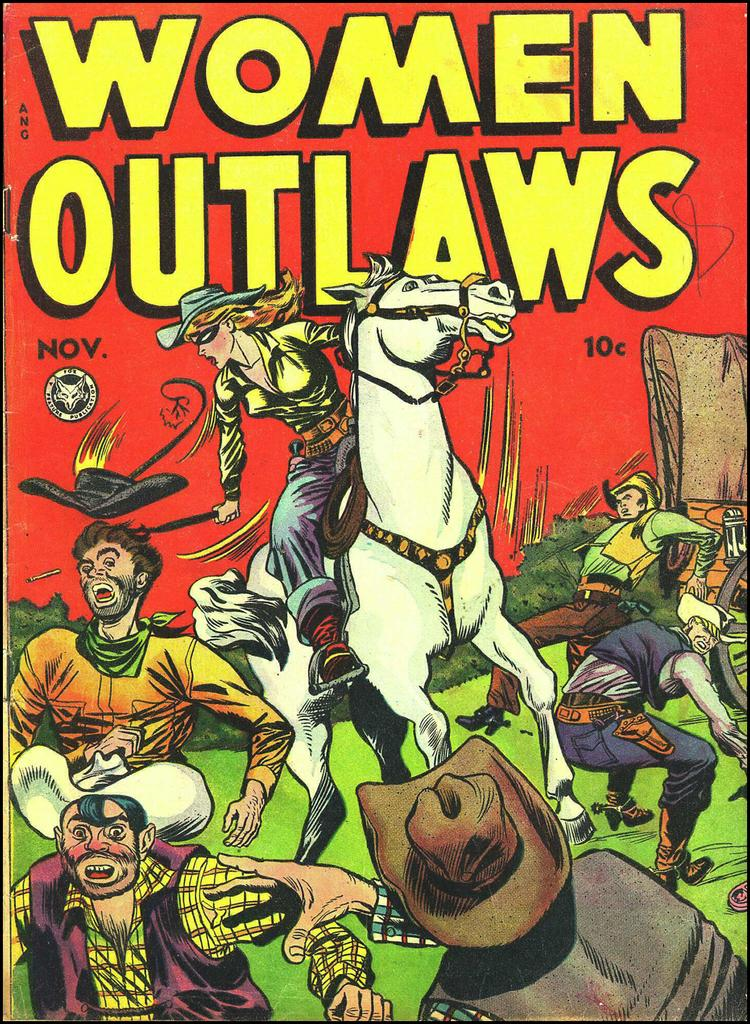<image>
Provide a brief description of the given image. Women outlaws book that is a fox feature publication 